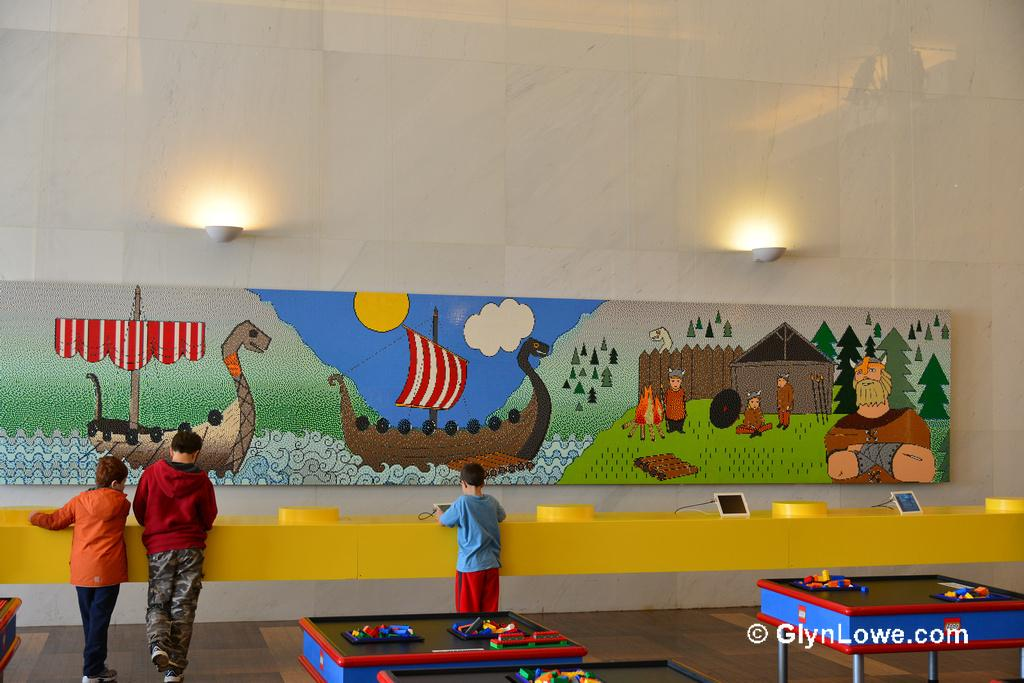How many boys are in the image? There are three boys in the image. What are the boys doing in the image? The boys are standing in the image. What objects can be seen in the image besides the boys? There are tables, electronic devices, an art piece, and lights on the wall in the background of the image. What type of holiday is being celebrated in the image? There is no indication of a holiday being celebrated in the image. What disease is affecting the boys in the image? There is no indication of any disease affecting the boys in the image. 